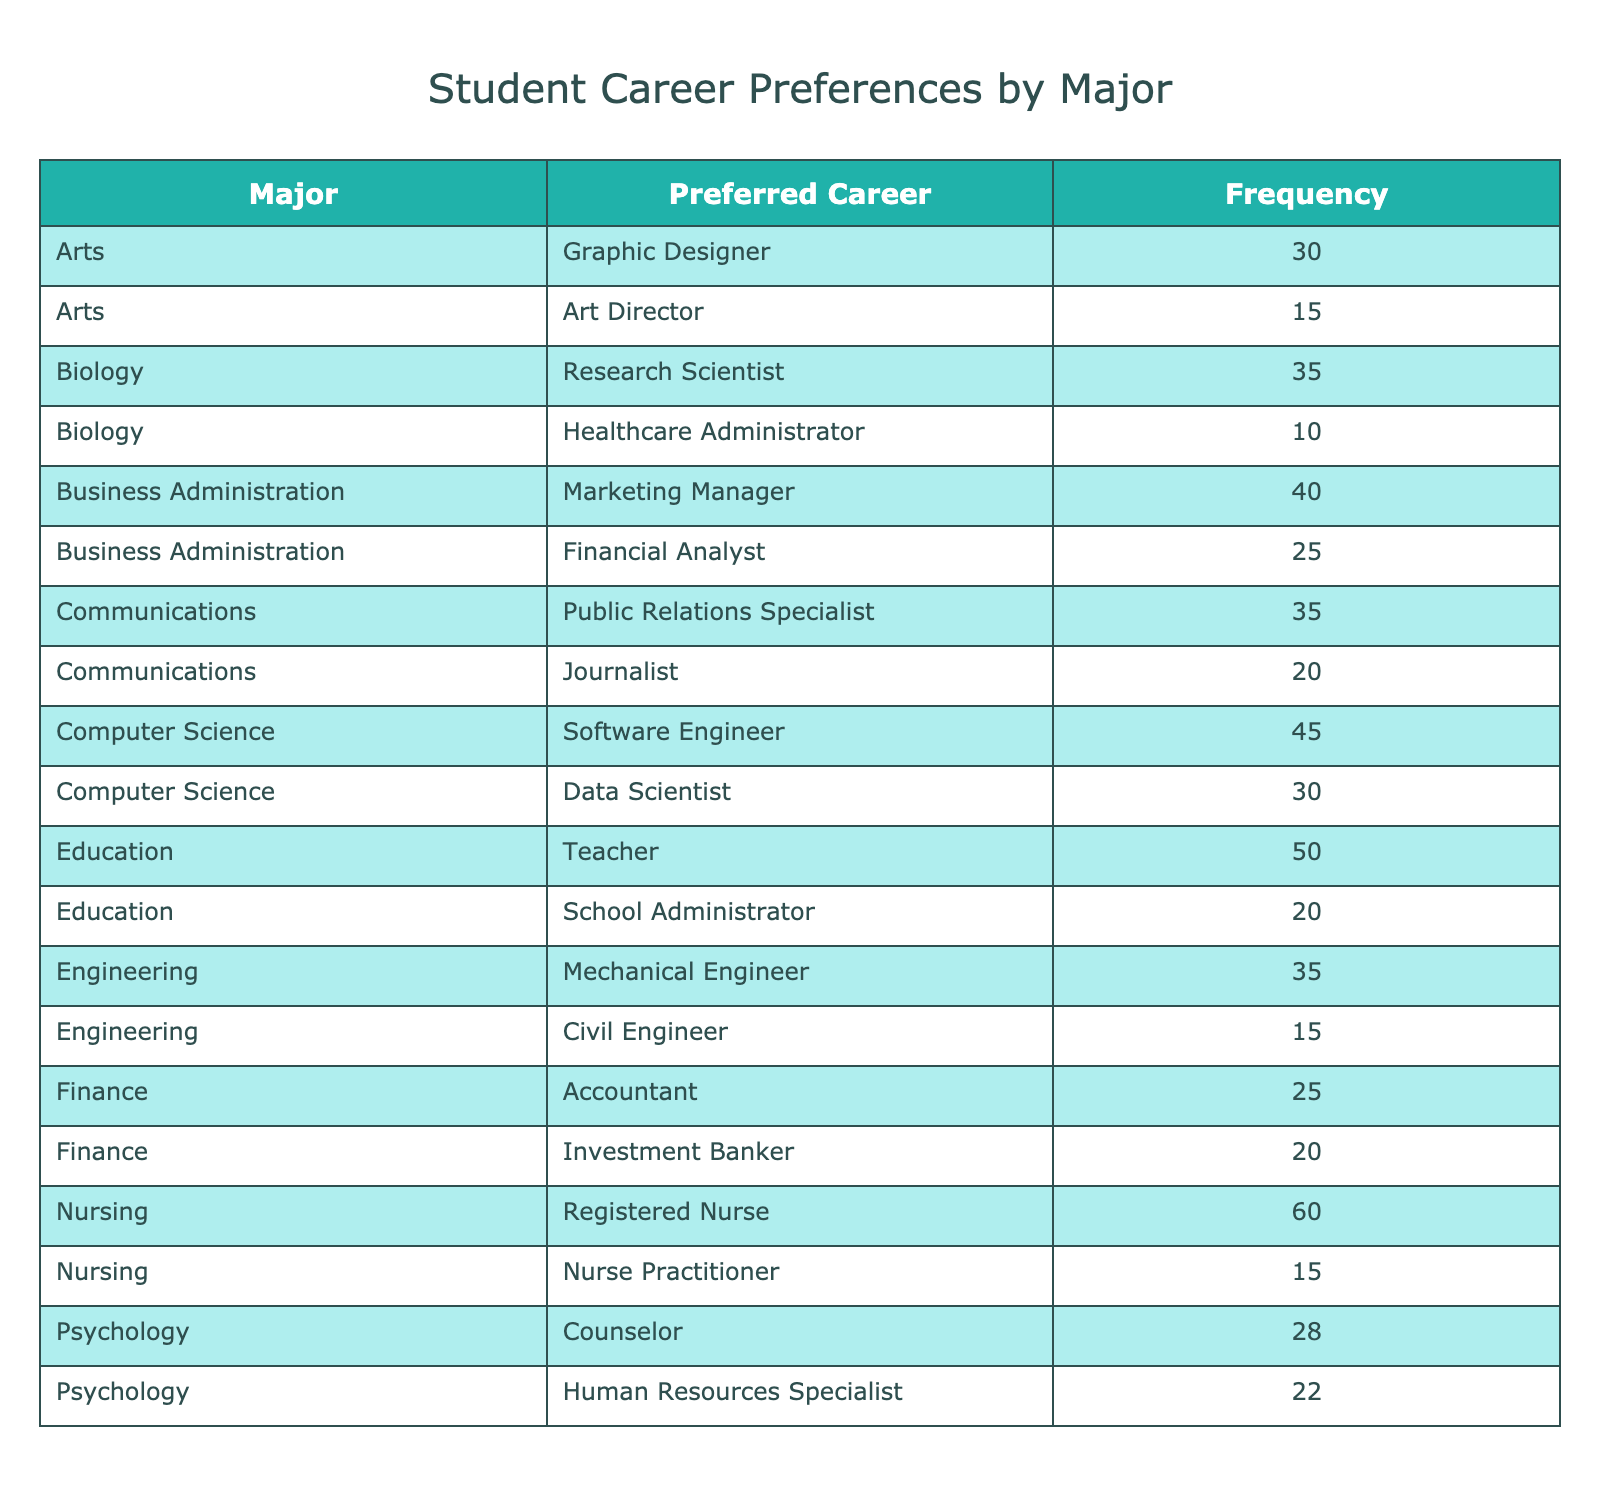What is the most preferred career for Biology majors? The table shows that 'Research Scientist' has the highest frequency of 35 among Biology majors.
Answer: Research Scientist How many students prefer Marketing Manager as a career? The frequency column indicates that 40 students prefer the Marketing Manager career, which corresponds to the Business Administration major.
Answer: 40 Is there a major that has more than 50 students preferring a specific career? By reviewing the table, we find that the Nursing major has 60 students preferring the Registered Nurse career, which is more than 50.
Answer: Yes What is the total number of students who prefer a career in Education? From the table, we see that 'Teacher' has a frequency of 50 and 'School Administrator' has a frequency of 20. Adding these gives us 50 + 20 = 70.
Answer: 70 Which career has the lowest frequency and what is that frequency? Looking through the table, we see that 'Healthcare Administrator' has the lowest frequency of 10.
Answer: 10 Are there more students who prefer being a Software Engineer or a Data Scientist in Computer Science? The frequency for Software Engineer is 45 and for Data Scientist it is 30. Since 45 > 30, more students prefer being a Software Engineer.
Answer: Yes What is the combined frequency of students who want to be in the field of Psychology? The preferred careers for Psychology are 'Counselor' (28 students) and 'Human Resources Specialist' (22 students). Adding these gives us 28 + 22 = 50.
Answer: 50 Which major has the second highest number of students preferring a specific career? Among the majors, Nursing has the highest preference with 60. The next highest is Education with 70 (50 for Teacher and 20 for School Administrator). Thus, Education is the second highest.
Answer: Education If we compare the frequencies, is the total number of students preferring careers in Engineering greater than those in Arts? Total for Engineering is 15 (Civil Engineer) + 35 (Mechanical Engineer) = 50 and for Arts is 30 (Graphic Designer) + 15 (Art Director) = 45. Since 50 > 45, Engineering has more students preferring these careers.
Answer: Yes 